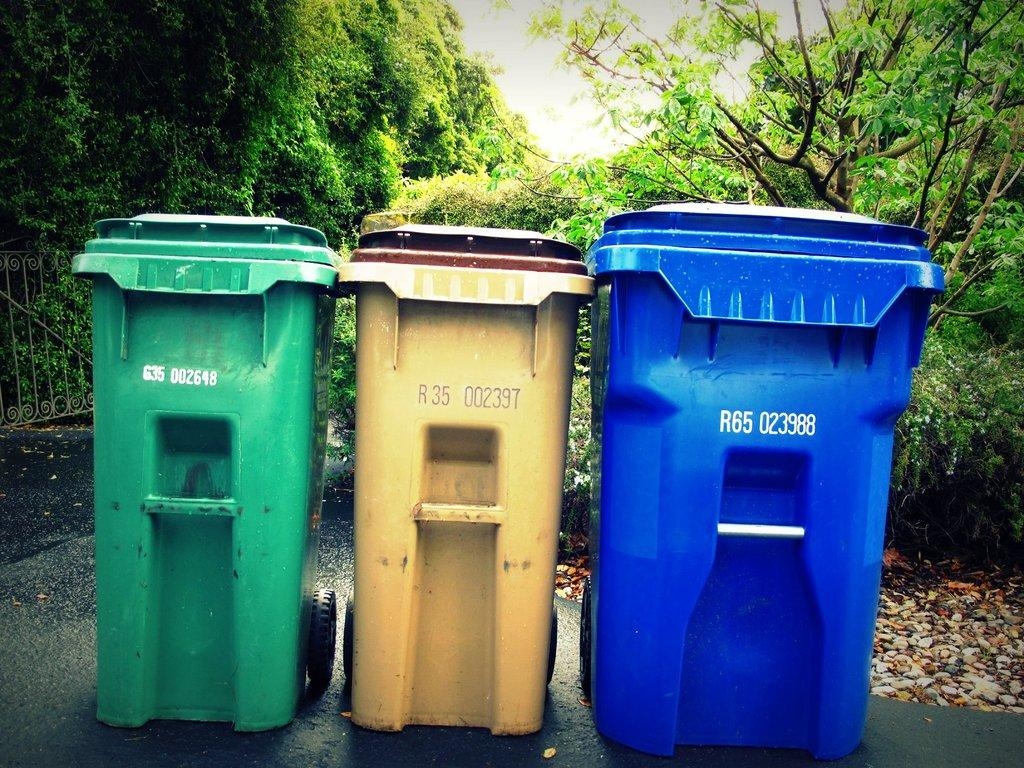Provide a one-sentence caption for the provided image. Three bins, the rightmost of which says R65 023988. 